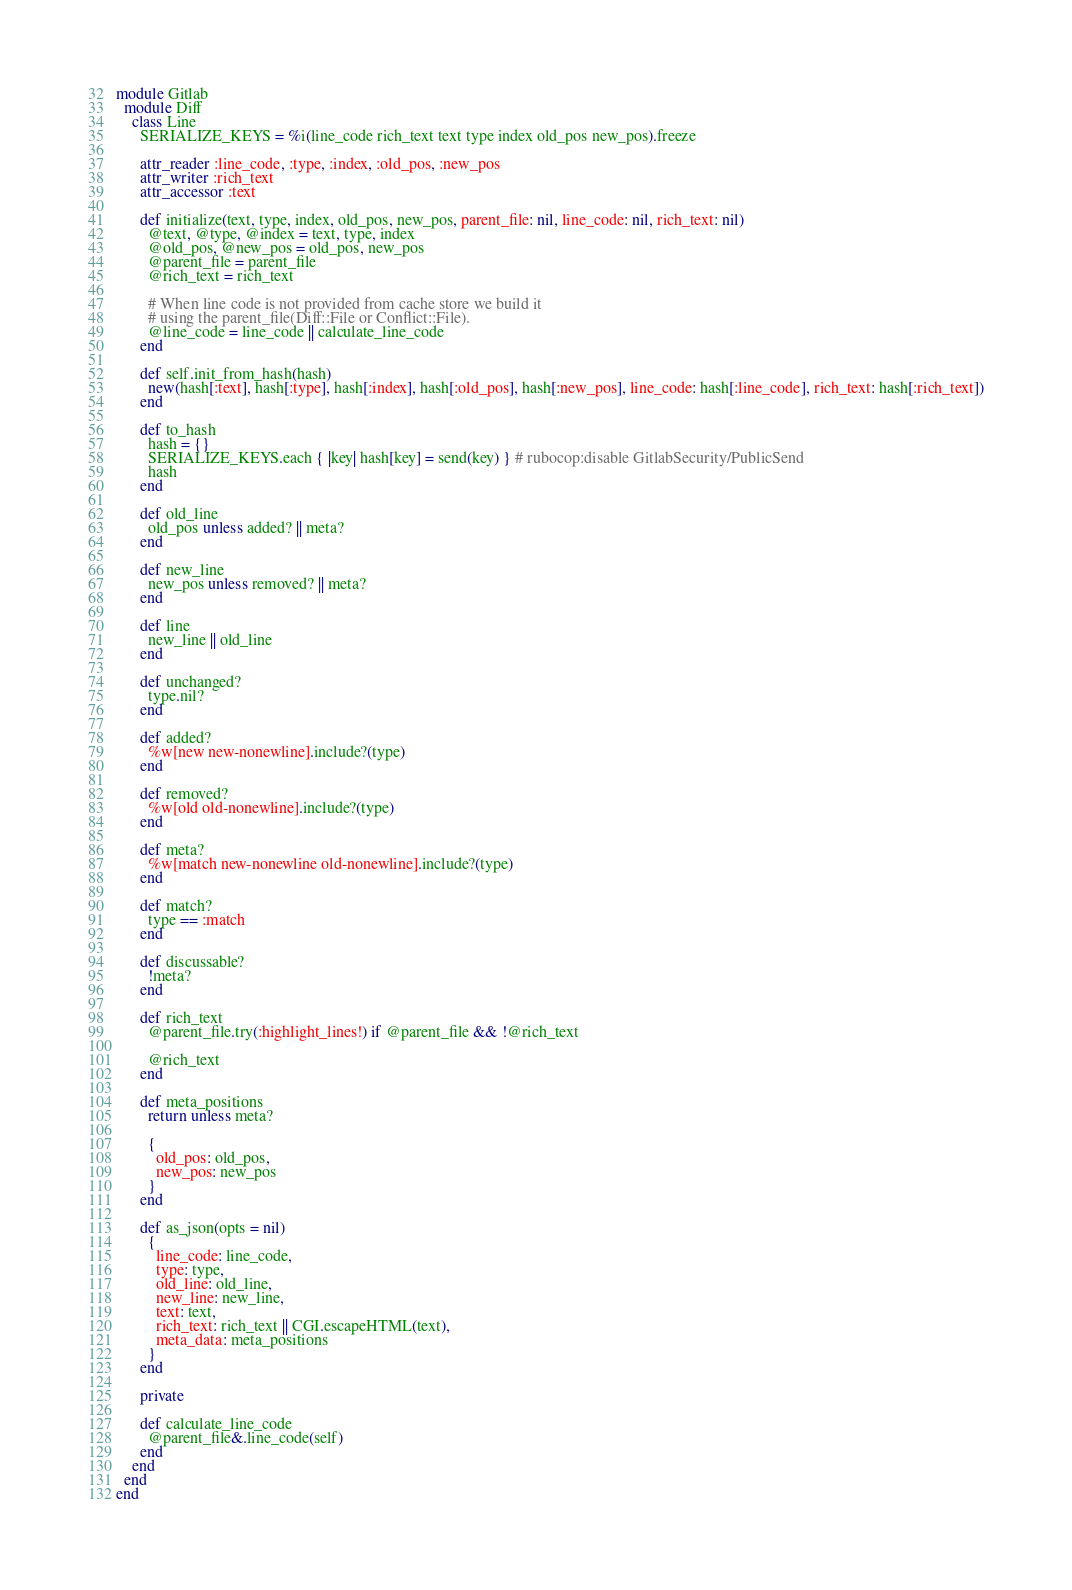Convert code to text. <code><loc_0><loc_0><loc_500><loc_500><_Ruby_>module Gitlab
  module Diff
    class Line
      SERIALIZE_KEYS = %i(line_code rich_text text type index old_pos new_pos).freeze

      attr_reader :line_code, :type, :index, :old_pos, :new_pos
      attr_writer :rich_text
      attr_accessor :text

      def initialize(text, type, index, old_pos, new_pos, parent_file: nil, line_code: nil, rich_text: nil)
        @text, @type, @index = text, type, index
        @old_pos, @new_pos = old_pos, new_pos
        @parent_file = parent_file
        @rich_text = rich_text

        # When line code is not provided from cache store we build it
        # using the parent_file(Diff::File or Conflict::File).
        @line_code = line_code || calculate_line_code
      end

      def self.init_from_hash(hash)
        new(hash[:text], hash[:type], hash[:index], hash[:old_pos], hash[:new_pos], line_code: hash[:line_code], rich_text: hash[:rich_text])
      end

      def to_hash
        hash = {}
        SERIALIZE_KEYS.each { |key| hash[key] = send(key) } # rubocop:disable GitlabSecurity/PublicSend
        hash
      end

      def old_line
        old_pos unless added? || meta?
      end

      def new_line
        new_pos unless removed? || meta?
      end

      def line
        new_line || old_line
      end

      def unchanged?
        type.nil?
      end

      def added?
        %w[new new-nonewline].include?(type)
      end

      def removed?
        %w[old old-nonewline].include?(type)
      end

      def meta?
        %w[match new-nonewline old-nonewline].include?(type)
      end

      def match?
        type == :match
      end

      def discussable?
        !meta?
      end

      def rich_text
        @parent_file.try(:highlight_lines!) if @parent_file && !@rich_text

        @rich_text
      end

      def meta_positions
        return unless meta?

        {
          old_pos: old_pos,
          new_pos: new_pos
        }
      end

      def as_json(opts = nil)
        {
          line_code: line_code,
          type: type,
          old_line: old_line,
          new_line: new_line,
          text: text,
          rich_text: rich_text || CGI.escapeHTML(text),
          meta_data: meta_positions
        }
      end

      private

      def calculate_line_code
        @parent_file&.line_code(self)
      end
    end
  end
end
</code> 